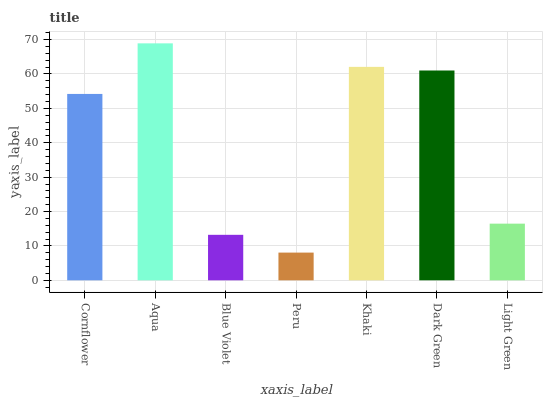Is Peru the minimum?
Answer yes or no. Yes. Is Aqua the maximum?
Answer yes or no. Yes. Is Blue Violet the minimum?
Answer yes or no. No. Is Blue Violet the maximum?
Answer yes or no. No. Is Aqua greater than Blue Violet?
Answer yes or no. Yes. Is Blue Violet less than Aqua?
Answer yes or no. Yes. Is Blue Violet greater than Aqua?
Answer yes or no. No. Is Aqua less than Blue Violet?
Answer yes or no. No. Is Cornflower the high median?
Answer yes or no. Yes. Is Cornflower the low median?
Answer yes or no. Yes. Is Khaki the high median?
Answer yes or no. No. Is Light Green the low median?
Answer yes or no. No. 